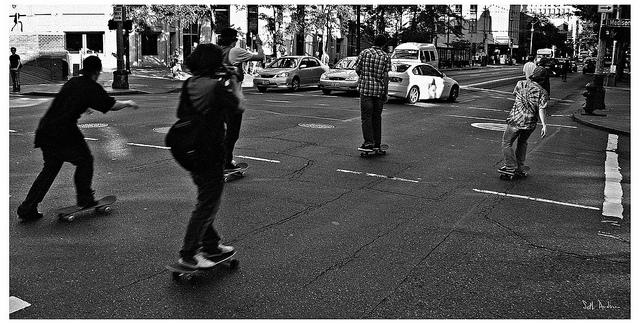What type of shirt is the man on the right wearing? tie dye 